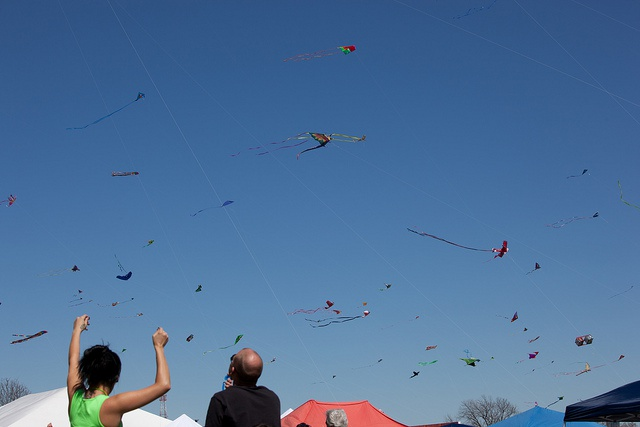Describe the objects in this image and their specific colors. I can see kite in blue, gray, and darkgray tones, people in blue, black, brown, and tan tones, people in blue, black, brown, and maroon tones, kite in blue, gray, and black tones, and kite in blue, purple, and teal tones in this image. 